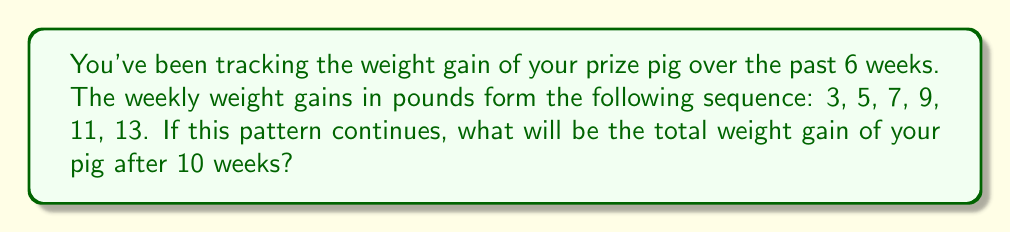Can you solve this math problem? Let's approach this step-by-step:

1) First, we need to recognize the pattern in the given sequence:
   3, 5, 7, 9, 11, 13

2) We can see that each term increases by 2 from the previous term. This is an arithmetic sequence with a common difference of 2.

3) The general term of an arithmetic sequence is given by:
   $a_n = a_1 + (n-1)d$
   where $a_n$ is the nth term, $a_1$ is the first term, n is the position, and d is the common difference.

4) In this case, $a_1 = 3$ and $d = 2$

5) We need to find the sum of the first 10 terms. The formula for the sum of an arithmetic sequence is:
   $S_n = \frac{n}{2}(a_1 + a_n)$
   where $S_n$ is the sum of n terms, and $a_n$ is the nth term.

6) We need to find $a_{10}$ first:
   $a_{10} = 3 + (10-1)2 = 3 + 18 = 21$

7) Now we can calculate the sum:
   $S_{10} = \frac{10}{2}(3 + 21) = 5(24) = 120$

Therefore, the total weight gain after 10 weeks will be 120 pounds.
Answer: 120 pounds 